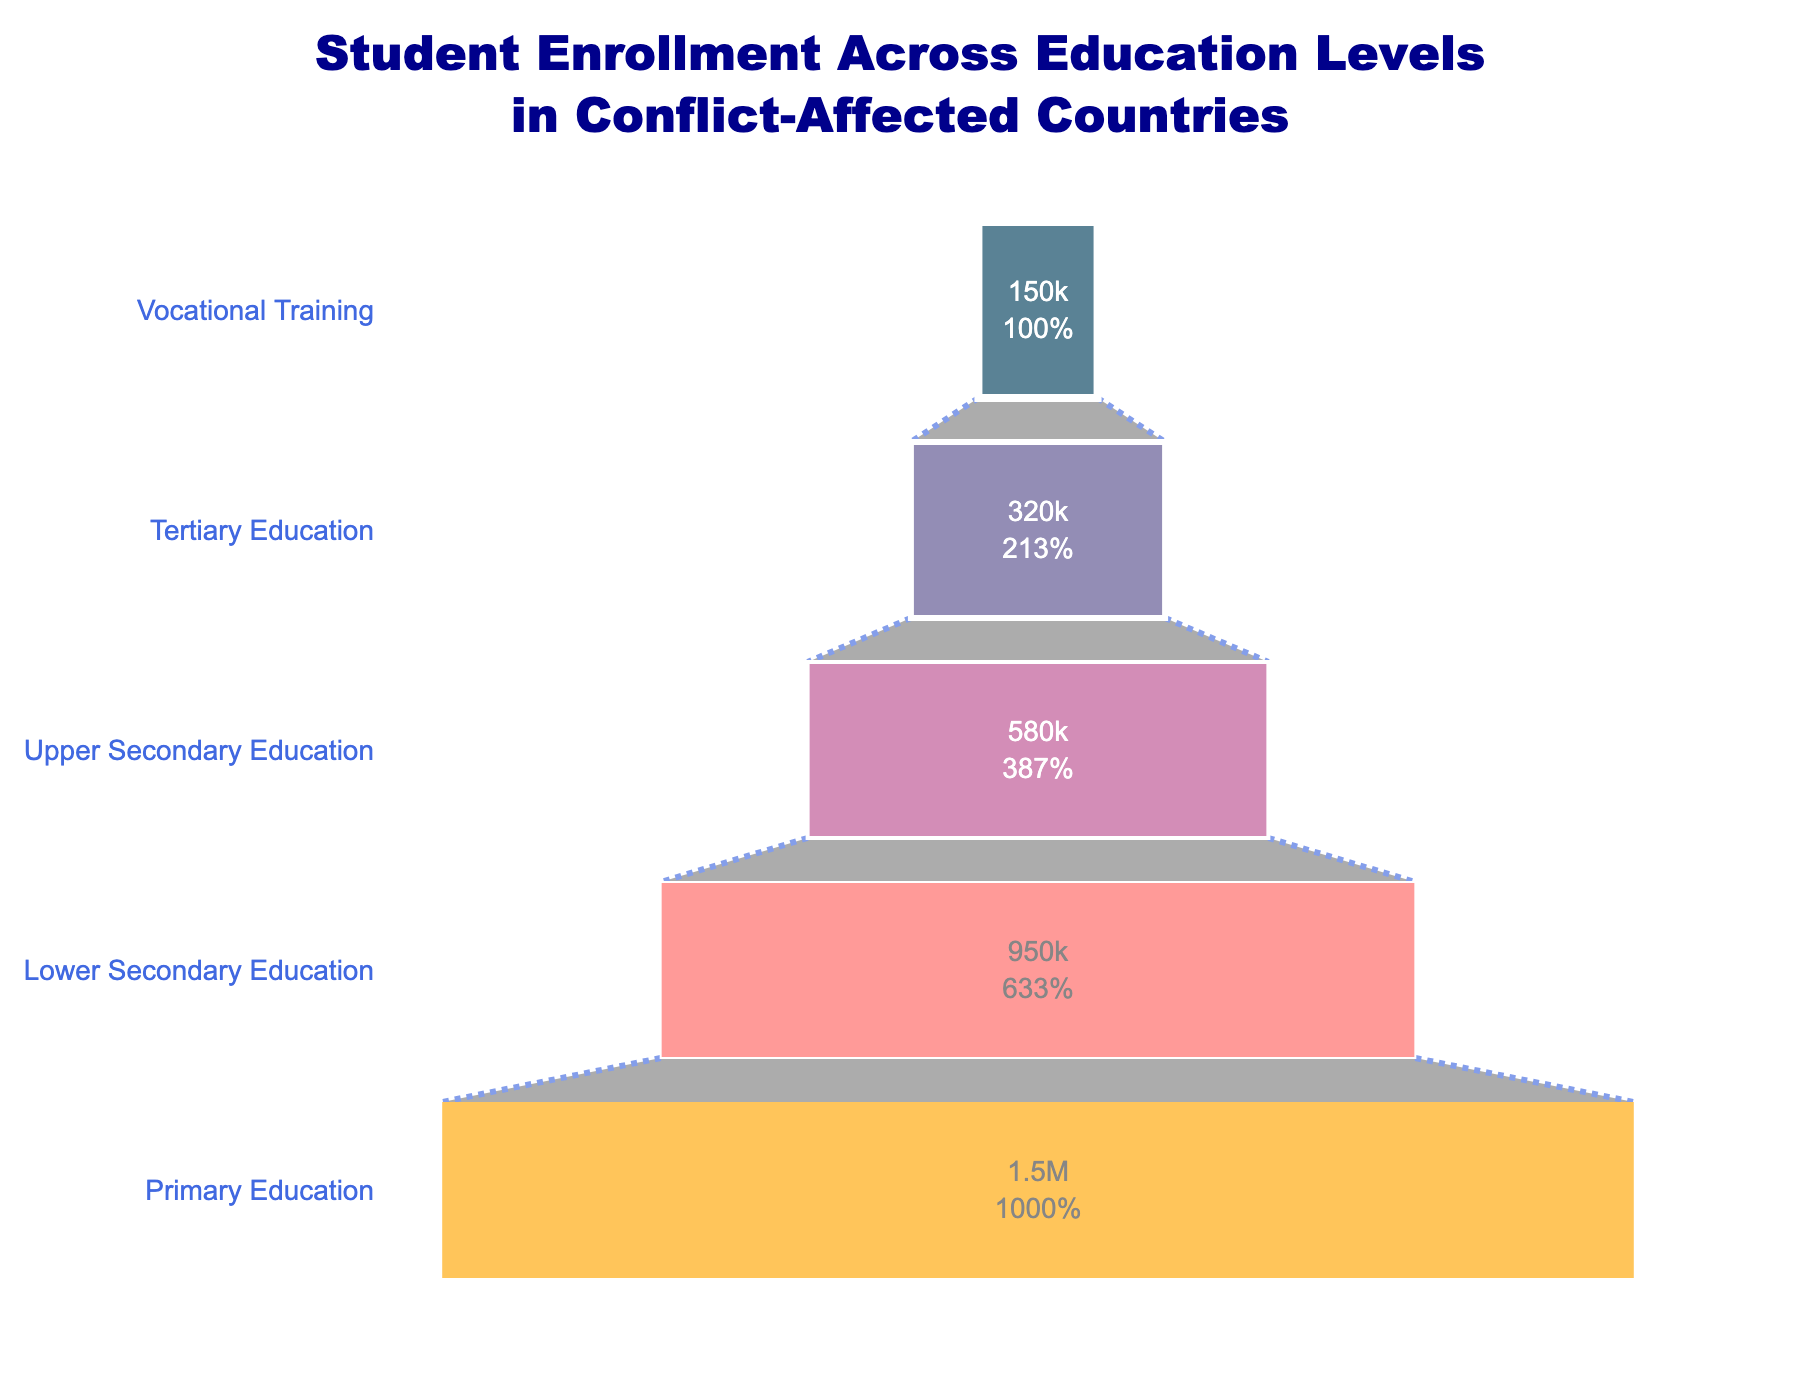What is the title of the figure? The title of the figure is displayed at the top and often provides a summary or main point of the figure. The title of this figure reads, "Student Enrollment Across Education Levels in Conflict-Affected Countries".
Answer: Student Enrollment Across Education Levels in Conflict-Affected Countries How many students are enrolled in Primary Education? The number of students enrolled in Primary Education is represented by the bar at the top of the funnel chart. From the data, it shows that there are 1,500,000 students.
Answer: 1,500,000 Which education level has the least number of students enrolled? By looking at the smallest section at the bottom of the funnel chart, you can determine that Vocational Training has the least number of students enrolled, with 150,000 students.
Answer: Vocational Training By how much does the number of students in Lower Secondary Education exceed those in Upper Secondary Education? This requires subtracting the number of students in Upper Secondary Education from those in Lower Secondary Education: 950,000 - 580,000 = 370,000.
Answer: 370,000 What percentage of the initial number of students (Primary Education) does Tertiary Education represent? The funnel chart provides this percentage. The value for Tertiary Education is 320,000. To find the percentage: (320,000 / 1,500,000) * 100 = 21.33%.
Answer: 21.33% How does the number of students in Upper Secondary Education compare to those in Tertiary Education? By comparing the sizes of the bars, it is evident that Upper Secondary Education has more students (580,000) compared to Tertiary Education (320,000).
Answer: Upper Secondary Education has more students How many students are enrolled in education levels below Tertiary Education? Sum the number of students in Primary, Lower Secondary, and Upper Secondary Education: 1,500,000 + 950,000 + 580,000 = 3,030,000.
Answer: 3,030,000 What is the difference in student numbers between the highest and the lowest enrollment levels? Subtract the number of students in Vocational Training (150,000) from those in Primary Education (1,500,000): 1,500,000 - 150,000 = 1,350,000.
Answer: 1,350,000 Which color is used to represent Lower Secondary Education on the chart? The color order from top to bottom corresponds to the entries. Lower Secondary Education is the second from the top, represented by a shade of purple.
Answer: purple (or "#58508d") 